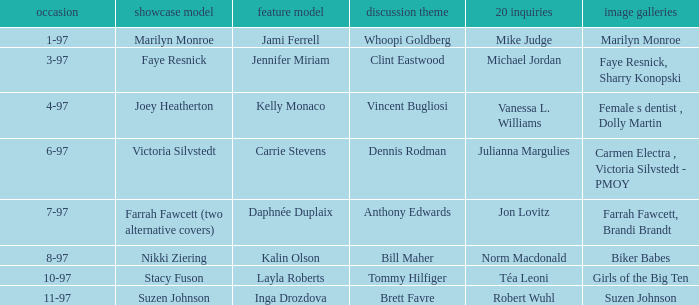What year was kalin olson's centerfold model appearance? 8-97. 